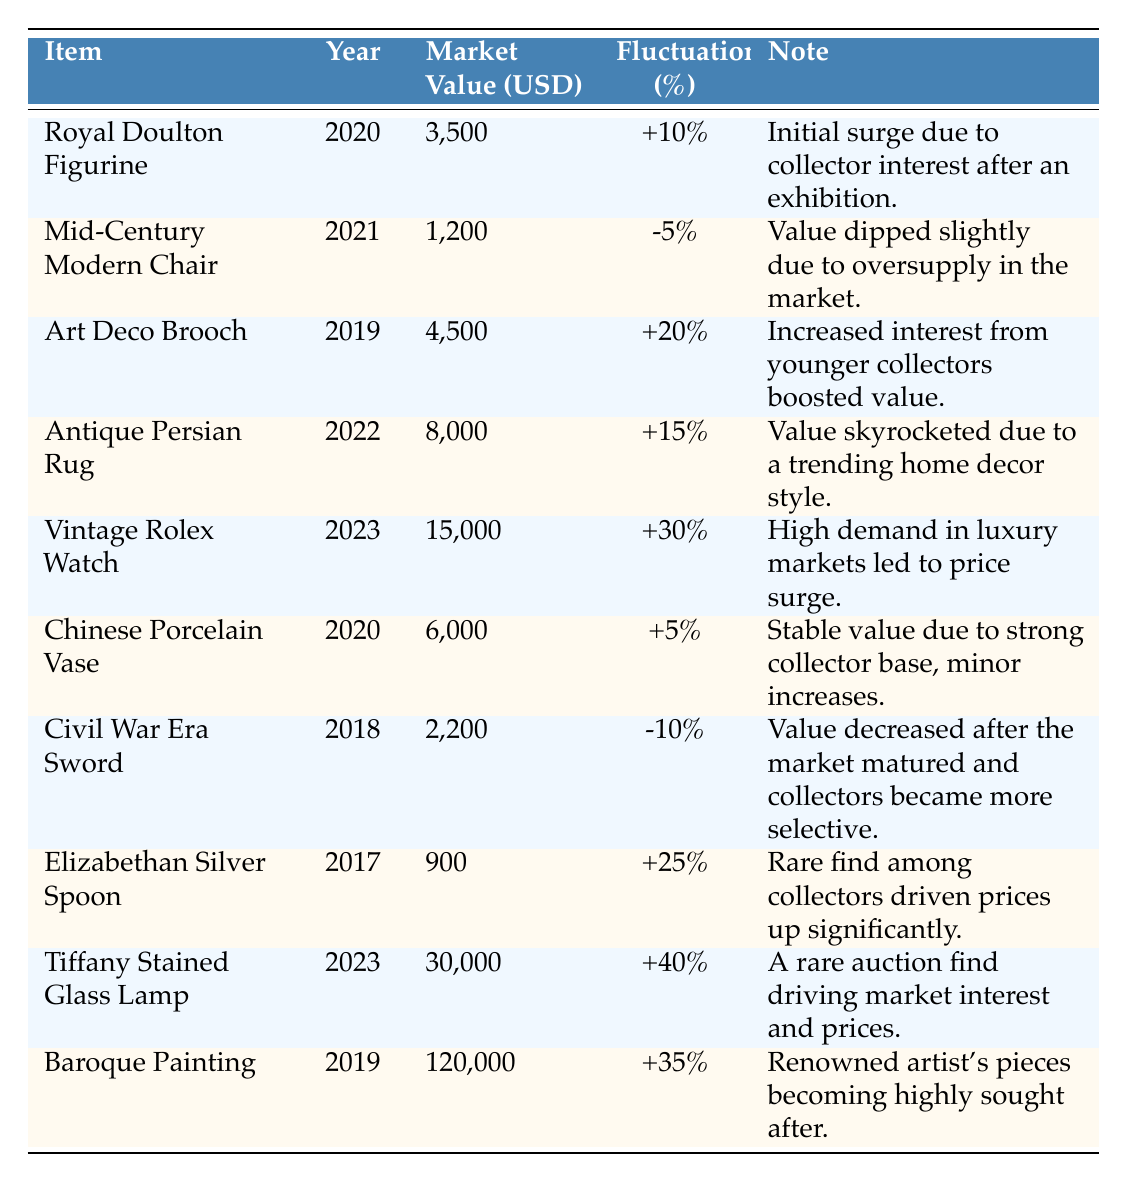What is the market value of the Tiffany Stained Glass Lamp? The table shows that the market value of the Tiffany Stained Glass Lamp is listed as 30,000 USD.
Answer: 30,000 USD Which item had the highest fluctuation percentage and what was that percentage? From the table, the Tiffany Stained Glass Lamp had the highest fluctuation percentage of +40%.
Answer: +40% How much did the Antique Persian Rug increase in value? The Antique Persian Rug's market value increased by 15% from its previous value, indicating a significant upward trend in demand.
Answer: 15% Was there any item that experienced a negative market value fluctuation? Yes, the Mid-Century Modern Chair had a fluctuation of -5%, indicating a decrease in value.
Answer: Yes Calculate the total market value of the items listed for the year 2023. Adding the values for 2023: 15,000 (Vintage Rolex Watch) + 30,000 (Tiffany Stained Glass Lamp) equals 45,000 USD.
Answer: 45,000 USD How many items were listed in total? The table contains 10 distinct antique treasures listed.
Answer: 10 Which item saw the greatest increase in market value from the previous year? The Vintage Rolex Watch had a 30% increase in value, which is the highest among those listed in the table.
Answer: Vintage Rolex Watch What was the market value of the Civil War Era Sword in 2018? The Civil War Era Sword had a market value of 2,200 USD in the year 2018 according to the table.
Answer: 2,200 USD Is the Royal Doulton Figurine's market value higher than the Elizabethan Silver Spoon? Yes, the Royal Doulton Figurine is valued at 3,500 USD, which is higher than the Elizabethan Silver Spoon priced at 900 USD.
Answer: Yes What is the average market value of items listed before the year 2020? The average for items listed before 2020 is calculated from the values: (2,200 + 900 + 4,500) / 3 = 2,200 USD approximately.
Answer: 2,200 USD What percentage change did the Art Deco Brooch experience? The Art Deco Brooch had an increase of +20% in its market fluctuation according to the table.
Answer: +20% Identify the year with the highest market value fluctuation percentage and specify the item. The year 2023 had the highest fluctuation percentage with the Tiffany Stained Glass Lamp at +40%.
Answer: 2023, Tiffany Stained Glass Lamp 